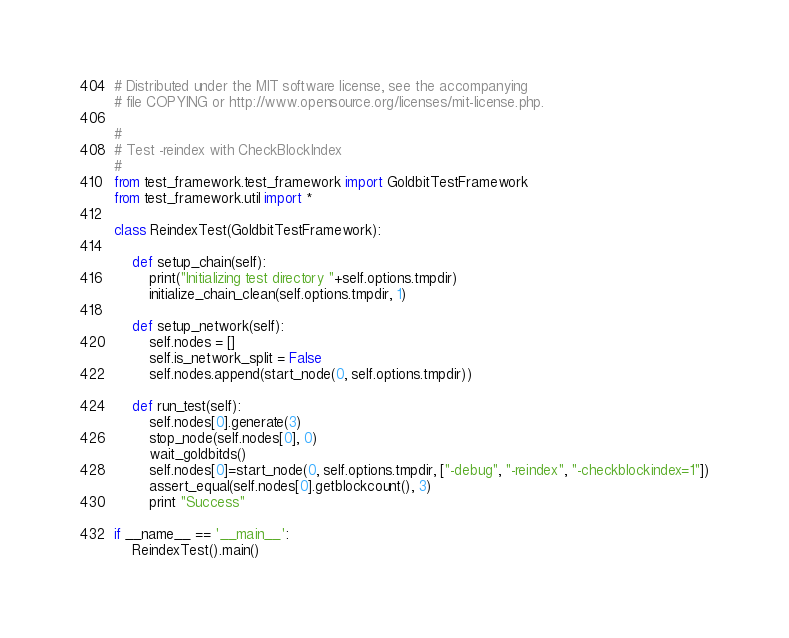Convert code to text. <code><loc_0><loc_0><loc_500><loc_500><_Python_># Distributed under the MIT software license, see the accompanying
# file COPYING or http://www.opensource.org/licenses/mit-license.php.

#
# Test -reindex with CheckBlockIndex
#
from test_framework.test_framework import GoldbitTestFramework
from test_framework.util import *

class ReindexTest(GoldbitTestFramework):

    def setup_chain(self):
        print("Initializing test directory "+self.options.tmpdir)
        initialize_chain_clean(self.options.tmpdir, 1)

    def setup_network(self):
        self.nodes = []
        self.is_network_split = False
        self.nodes.append(start_node(0, self.options.tmpdir))

    def run_test(self):
        self.nodes[0].generate(3)
        stop_node(self.nodes[0], 0)
        wait_goldbitds()
        self.nodes[0]=start_node(0, self.options.tmpdir, ["-debug", "-reindex", "-checkblockindex=1"])
        assert_equal(self.nodes[0].getblockcount(), 3)
        print "Success"

if __name__ == '__main__':
    ReindexTest().main()
</code> 